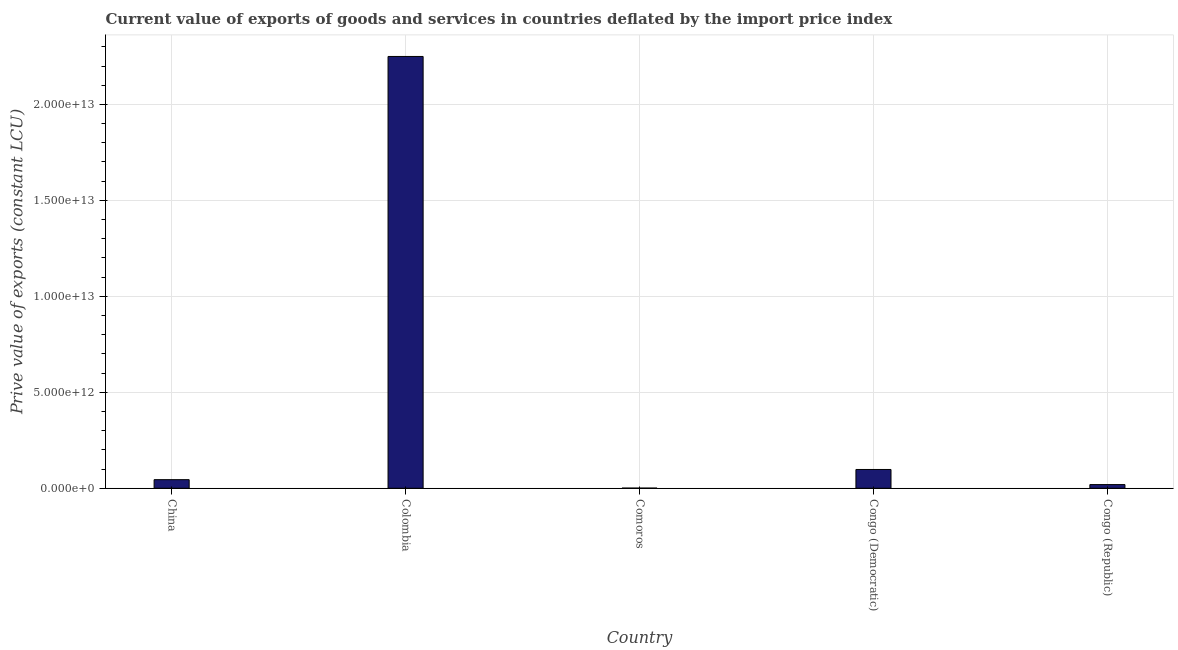Does the graph contain grids?
Offer a very short reply. Yes. What is the title of the graph?
Offer a very short reply. Current value of exports of goods and services in countries deflated by the import price index. What is the label or title of the X-axis?
Provide a succinct answer. Country. What is the label or title of the Y-axis?
Keep it short and to the point. Prive value of exports (constant LCU). What is the price value of exports in China?
Make the answer very short. 4.49e+11. Across all countries, what is the maximum price value of exports?
Your response must be concise. 2.25e+13. Across all countries, what is the minimum price value of exports?
Provide a succinct answer. 9.83e+09. In which country was the price value of exports minimum?
Offer a terse response. Comoros. What is the sum of the price value of exports?
Keep it short and to the point. 2.41e+13. What is the difference between the price value of exports in Congo (Democratic) and Congo (Republic)?
Offer a very short reply. 7.87e+11. What is the average price value of exports per country?
Provide a succinct answer. 4.83e+12. What is the median price value of exports?
Your response must be concise. 4.49e+11. In how many countries, is the price value of exports greater than 18000000000000 LCU?
Keep it short and to the point. 1. What is the ratio of the price value of exports in China to that in Congo (Republic)?
Ensure brevity in your answer.  2.33. What is the difference between the highest and the second highest price value of exports?
Your answer should be very brief. 2.15e+13. Is the sum of the price value of exports in Colombia and Congo (Democratic) greater than the maximum price value of exports across all countries?
Ensure brevity in your answer.  Yes. What is the difference between the highest and the lowest price value of exports?
Offer a very short reply. 2.25e+13. What is the difference between two consecutive major ticks on the Y-axis?
Keep it short and to the point. 5.00e+12. Are the values on the major ticks of Y-axis written in scientific E-notation?
Provide a succinct answer. Yes. What is the Prive value of exports (constant LCU) in China?
Your answer should be very brief. 4.49e+11. What is the Prive value of exports (constant LCU) in Colombia?
Give a very brief answer. 2.25e+13. What is the Prive value of exports (constant LCU) of Comoros?
Make the answer very short. 9.83e+09. What is the Prive value of exports (constant LCU) of Congo (Democratic)?
Your answer should be very brief. 9.80e+11. What is the Prive value of exports (constant LCU) of Congo (Republic)?
Give a very brief answer. 1.93e+11. What is the difference between the Prive value of exports (constant LCU) in China and Colombia?
Your answer should be compact. -2.20e+13. What is the difference between the Prive value of exports (constant LCU) in China and Comoros?
Make the answer very short. 4.39e+11. What is the difference between the Prive value of exports (constant LCU) in China and Congo (Democratic)?
Provide a succinct answer. -5.30e+11. What is the difference between the Prive value of exports (constant LCU) in China and Congo (Republic)?
Your response must be concise. 2.56e+11. What is the difference between the Prive value of exports (constant LCU) in Colombia and Comoros?
Your answer should be very brief. 2.25e+13. What is the difference between the Prive value of exports (constant LCU) in Colombia and Congo (Democratic)?
Offer a terse response. 2.15e+13. What is the difference between the Prive value of exports (constant LCU) in Colombia and Congo (Republic)?
Ensure brevity in your answer.  2.23e+13. What is the difference between the Prive value of exports (constant LCU) in Comoros and Congo (Democratic)?
Keep it short and to the point. -9.70e+11. What is the difference between the Prive value of exports (constant LCU) in Comoros and Congo (Republic)?
Make the answer very short. -1.83e+11. What is the difference between the Prive value of exports (constant LCU) in Congo (Democratic) and Congo (Republic)?
Your answer should be very brief. 7.87e+11. What is the ratio of the Prive value of exports (constant LCU) in China to that in Colombia?
Offer a terse response. 0.02. What is the ratio of the Prive value of exports (constant LCU) in China to that in Comoros?
Offer a very short reply. 45.69. What is the ratio of the Prive value of exports (constant LCU) in China to that in Congo (Democratic)?
Your answer should be compact. 0.46. What is the ratio of the Prive value of exports (constant LCU) in China to that in Congo (Republic)?
Give a very brief answer. 2.33. What is the ratio of the Prive value of exports (constant LCU) in Colombia to that in Comoros?
Ensure brevity in your answer.  2289.17. What is the ratio of the Prive value of exports (constant LCU) in Colombia to that in Congo (Democratic)?
Keep it short and to the point. 22.97. What is the ratio of the Prive value of exports (constant LCU) in Colombia to that in Congo (Republic)?
Offer a terse response. 116.86. What is the ratio of the Prive value of exports (constant LCU) in Comoros to that in Congo (Democratic)?
Provide a short and direct response. 0.01. What is the ratio of the Prive value of exports (constant LCU) in Comoros to that in Congo (Republic)?
Give a very brief answer. 0.05. What is the ratio of the Prive value of exports (constant LCU) in Congo (Democratic) to that in Congo (Republic)?
Your response must be concise. 5.09. 